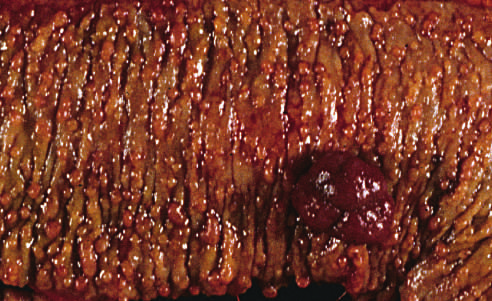what are present along with a dominant polyp (right)?
Answer the question using a single word or phrase. Hundreds of small colonic polyps 